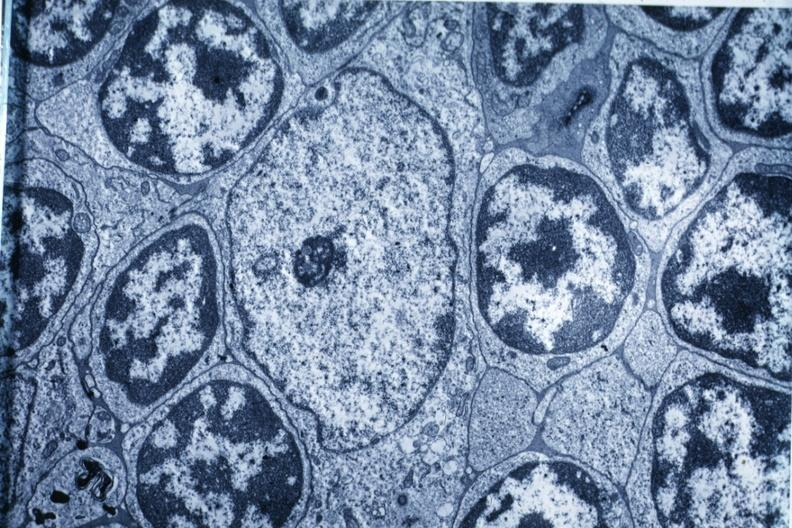what is present?
Answer the question using a single word or phrase. Hematologic 